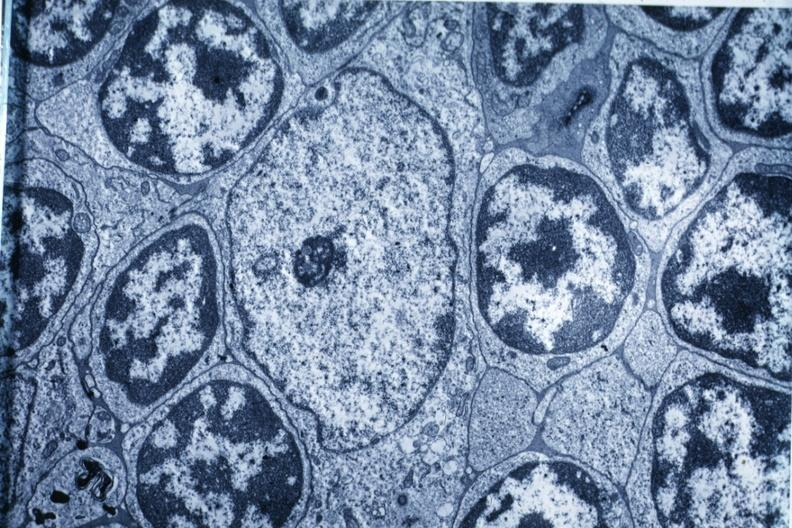what is present?
Answer the question using a single word or phrase. Hematologic 